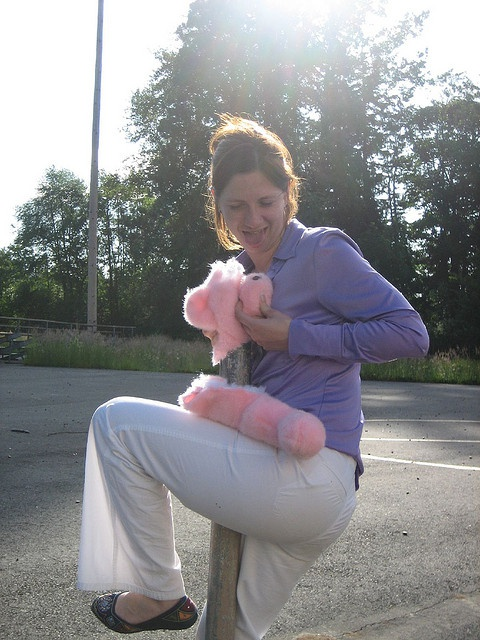Describe the objects in this image and their specific colors. I can see people in white, darkgray, and gray tones and teddy bear in white and gray tones in this image. 